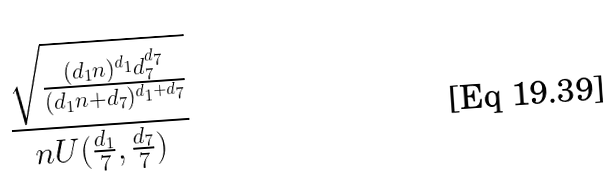<formula> <loc_0><loc_0><loc_500><loc_500>\frac { \sqrt { \frac { ( d _ { 1 } n ) ^ { d _ { 1 } } d _ { 7 } ^ { d _ { 7 } } } { ( d _ { 1 } n + d _ { 7 } ) ^ { d _ { 1 } + d _ { 7 } } } } } { n U ( \frac { d _ { 1 } } { 7 } , \frac { d _ { 7 } } { 7 } ) }</formula> 